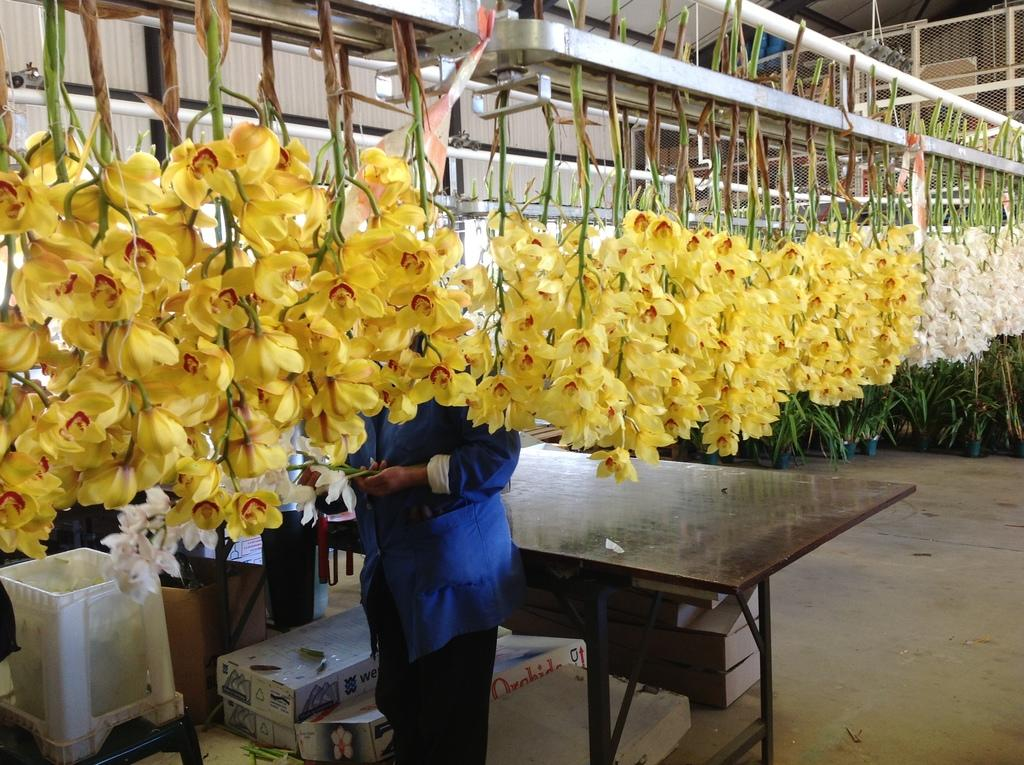What type of living organisms can be seen in the image? There are flowers in the image. Can you describe the presence of a person in the image? There is a person standing in the image. What type of yard can be seen in the image? There is no yard present in the image; it only features flowers and a person. How does the fan affect the appearance of the flowers in the image? There is no fan present in the image, so its effect on the flowers cannot be determined. 